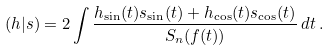Convert formula to latex. <formula><loc_0><loc_0><loc_500><loc_500>( h | s ) = 2 \int \frac { h _ { \sin } ( t ) s _ { \sin } ( t ) + h _ { \cos } ( t ) s _ { \cos } ( t ) } { S _ { n } ( f ( t ) ) } \, d t \, .</formula> 